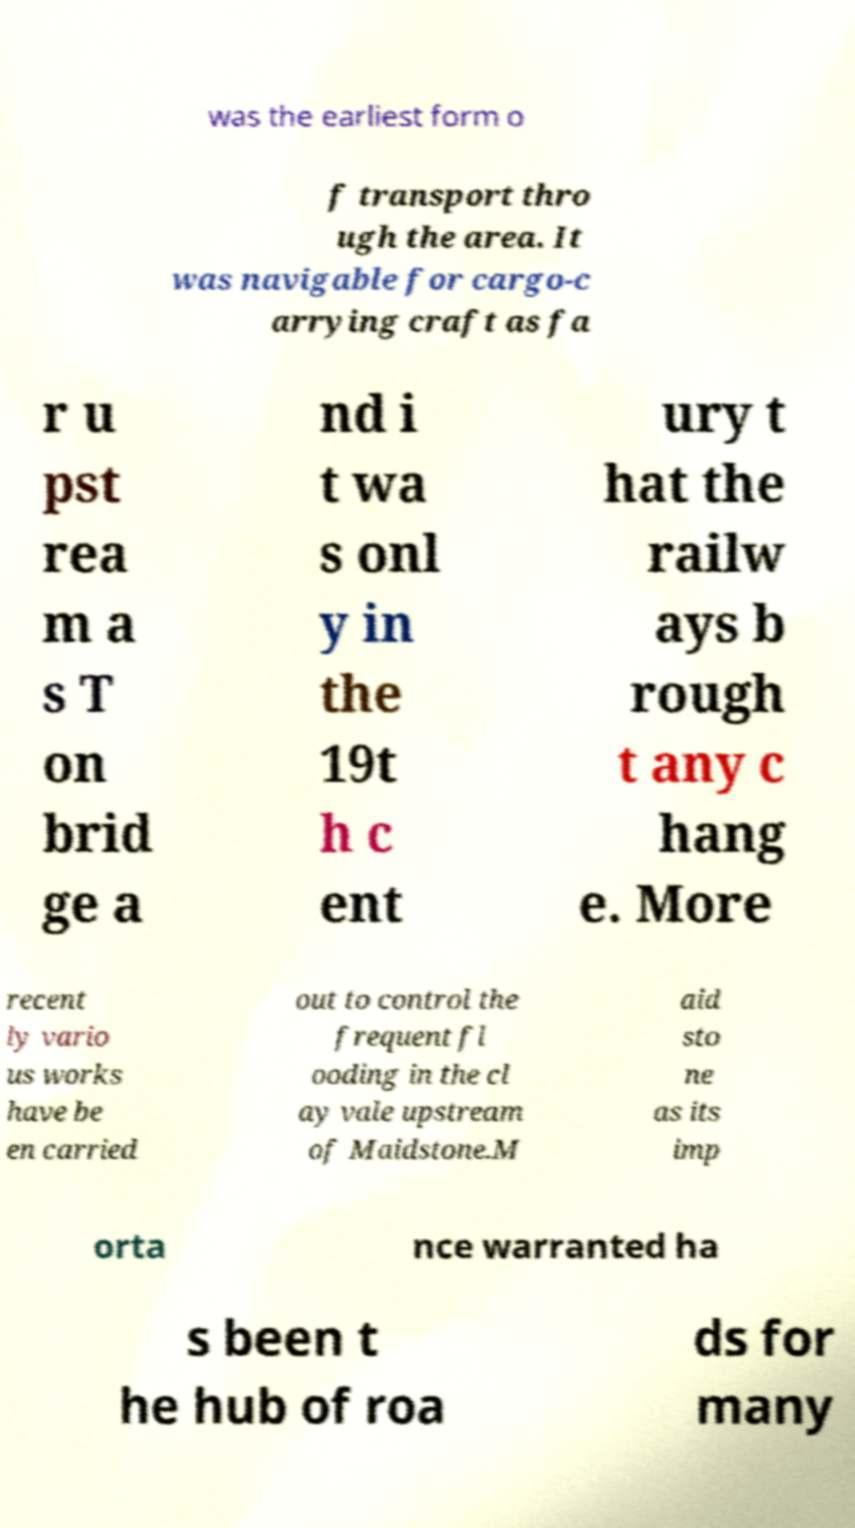For documentation purposes, I need the text within this image transcribed. Could you provide that? was the earliest form o f transport thro ugh the area. It was navigable for cargo-c arrying craft as fa r u pst rea m a s T on brid ge a nd i t wa s onl y in the 19t h c ent ury t hat the railw ays b rough t any c hang e. More recent ly vario us works have be en carried out to control the frequent fl ooding in the cl ay vale upstream of Maidstone.M aid sto ne as its imp orta nce warranted ha s been t he hub of roa ds for many 